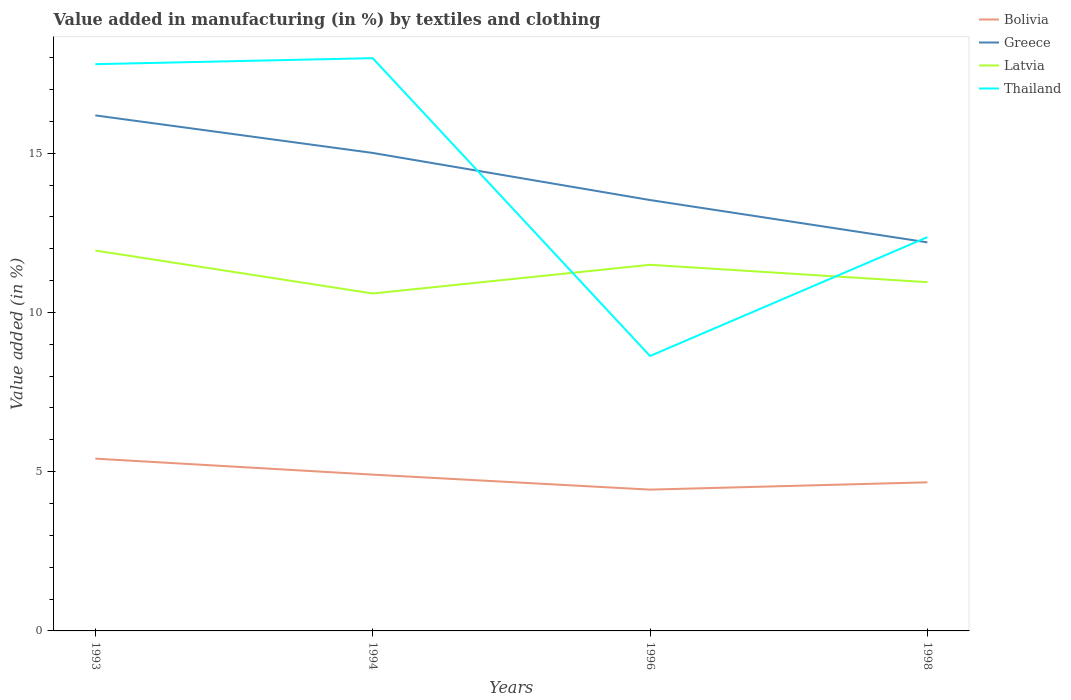How many different coloured lines are there?
Your response must be concise. 4. Across all years, what is the maximum percentage of value added in manufacturing by textiles and clothing in Latvia?
Provide a short and direct response. 10.59. What is the total percentage of value added in manufacturing by textiles and clothing in Greece in the graph?
Provide a succinct answer. 1.18. What is the difference between the highest and the second highest percentage of value added in manufacturing by textiles and clothing in Bolivia?
Keep it short and to the point. 0.97. Is the percentage of value added in manufacturing by textiles and clothing in Latvia strictly greater than the percentage of value added in manufacturing by textiles and clothing in Bolivia over the years?
Keep it short and to the point. No. How many lines are there?
Ensure brevity in your answer.  4. What is the difference between two consecutive major ticks on the Y-axis?
Offer a terse response. 5. Are the values on the major ticks of Y-axis written in scientific E-notation?
Your answer should be compact. No. Does the graph contain any zero values?
Your answer should be very brief. No. What is the title of the graph?
Keep it short and to the point. Value added in manufacturing (in %) by textiles and clothing. Does "Vanuatu" appear as one of the legend labels in the graph?
Offer a terse response. No. What is the label or title of the Y-axis?
Make the answer very short. Value added (in %). What is the Value added (in %) in Bolivia in 1993?
Provide a short and direct response. 5.41. What is the Value added (in %) in Greece in 1993?
Keep it short and to the point. 16.19. What is the Value added (in %) of Latvia in 1993?
Offer a terse response. 11.94. What is the Value added (in %) in Thailand in 1993?
Your answer should be very brief. 17.79. What is the Value added (in %) in Bolivia in 1994?
Ensure brevity in your answer.  4.91. What is the Value added (in %) in Greece in 1994?
Make the answer very short. 15.01. What is the Value added (in %) in Latvia in 1994?
Your answer should be very brief. 10.59. What is the Value added (in %) of Thailand in 1994?
Make the answer very short. 17.98. What is the Value added (in %) of Bolivia in 1996?
Offer a terse response. 4.44. What is the Value added (in %) of Greece in 1996?
Your answer should be very brief. 13.53. What is the Value added (in %) in Latvia in 1996?
Your answer should be compact. 11.5. What is the Value added (in %) of Thailand in 1996?
Make the answer very short. 8.63. What is the Value added (in %) in Bolivia in 1998?
Make the answer very short. 4.67. What is the Value added (in %) in Greece in 1998?
Provide a short and direct response. 12.2. What is the Value added (in %) of Latvia in 1998?
Make the answer very short. 10.95. What is the Value added (in %) of Thailand in 1998?
Your response must be concise. 12.36. Across all years, what is the maximum Value added (in %) of Bolivia?
Give a very brief answer. 5.41. Across all years, what is the maximum Value added (in %) of Greece?
Offer a terse response. 16.19. Across all years, what is the maximum Value added (in %) of Latvia?
Offer a terse response. 11.94. Across all years, what is the maximum Value added (in %) of Thailand?
Ensure brevity in your answer.  17.98. Across all years, what is the minimum Value added (in %) of Bolivia?
Provide a succinct answer. 4.44. Across all years, what is the minimum Value added (in %) in Greece?
Your answer should be compact. 12.2. Across all years, what is the minimum Value added (in %) of Latvia?
Your answer should be very brief. 10.59. Across all years, what is the minimum Value added (in %) of Thailand?
Provide a short and direct response. 8.63. What is the total Value added (in %) of Bolivia in the graph?
Offer a very short reply. 19.42. What is the total Value added (in %) of Greece in the graph?
Your response must be concise. 56.92. What is the total Value added (in %) in Latvia in the graph?
Your answer should be very brief. 44.98. What is the total Value added (in %) of Thailand in the graph?
Your answer should be compact. 56.77. What is the difference between the Value added (in %) of Bolivia in 1993 and that in 1994?
Make the answer very short. 0.5. What is the difference between the Value added (in %) in Greece in 1993 and that in 1994?
Make the answer very short. 1.18. What is the difference between the Value added (in %) of Latvia in 1993 and that in 1994?
Give a very brief answer. 1.35. What is the difference between the Value added (in %) in Thailand in 1993 and that in 1994?
Give a very brief answer. -0.19. What is the difference between the Value added (in %) in Bolivia in 1993 and that in 1996?
Provide a short and direct response. 0.97. What is the difference between the Value added (in %) of Greece in 1993 and that in 1996?
Provide a succinct answer. 2.66. What is the difference between the Value added (in %) in Latvia in 1993 and that in 1996?
Offer a terse response. 0.45. What is the difference between the Value added (in %) in Thailand in 1993 and that in 1996?
Make the answer very short. 9.16. What is the difference between the Value added (in %) in Bolivia in 1993 and that in 1998?
Ensure brevity in your answer.  0.74. What is the difference between the Value added (in %) of Greece in 1993 and that in 1998?
Your answer should be very brief. 3.99. What is the difference between the Value added (in %) of Thailand in 1993 and that in 1998?
Your response must be concise. 5.43. What is the difference between the Value added (in %) of Bolivia in 1994 and that in 1996?
Give a very brief answer. 0.47. What is the difference between the Value added (in %) in Greece in 1994 and that in 1996?
Offer a terse response. 1.48. What is the difference between the Value added (in %) in Latvia in 1994 and that in 1996?
Your answer should be very brief. -0.9. What is the difference between the Value added (in %) of Thailand in 1994 and that in 1996?
Provide a succinct answer. 9.35. What is the difference between the Value added (in %) of Bolivia in 1994 and that in 1998?
Provide a succinct answer. 0.24. What is the difference between the Value added (in %) in Greece in 1994 and that in 1998?
Provide a succinct answer. 2.81. What is the difference between the Value added (in %) of Latvia in 1994 and that in 1998?
Your answer should be compact. -0.35. What is the difference between the Value added (in %) in Thailand in 1994 and that in 1998?
Ensure brevity in your answer.  5.62. What is the difference between the Value added (in %) of Bolivia in 1996 and that in 1998?
Your answer should be very brief. -0.23. What is the difference between the Value added (in %) in Greece in 1996 and that in 1998?
Your answer should be very brief. 1.33. What is the difference between the Value added (in %) of Latvia in 1996 and that in 1998?
Offer a terse response. 0.55. What is the difference between the Value added (in %) in Thailand in 1996 and that in 1998?
Offer a terse response. -3.73. What is the difference between the Value added (in %) of Bolivia in 1993 and the Value added (in %) of Greece in 1994?
Your response must be concise. -9.6. What is the difference between the Value added (in %) in Bolivia in 1993 and the Value added (in %) in Latvia in 1994?
Provide a succinct answer. -5.19. What is the difference between the Value added (in %) of Bolivia in 1993 and the Value added (in %) of Thailand in 1994?
Keep it short and to the point. -12.57. What is the difference between the Value added (in %) in Greece in 1993 and the Value added (in %) in Latvia in 1994?
Offer a terse response. 5.59. What is the difference between the Value added (in %) of Greece in 1993 and the Value added (in %) of Thailand in 1994?
Provide a short and direct response. -1.8. What is the difference between the Value added (in %) in Latvia in 1993 and the Value added (in %) in Thailand in 1994?
Keep it short and to the point. -6.04. What is the difference between the Value added (in %) of Bolivia in 1993 and the Value added (in %) of Greece in 1996?
Keep it short and to the point. -8.12. What is the difference between the Value added (in %) of Bolivia in 1993 and the Value added (in %) of Latvia in 1996?
Provide a succinct answer. -6.09. What is the difference between the Value added (in %) of Bolivia in 1993 and the Value added (in %) of Thailand in 1996?
Ensure brevity in your answer.  -3.22. What is the difference between the Value added (in %) of Greece in 1993 and the Value added (in %) of Latvia in 1996?
Keep it short and to the point. 4.69. What is the difference between the Value added (in %) of Greece in 1993 and the Value added (in %) of Thailand in 1996?
Offer a terse response. 7.55. What is the difference between the Value added (in %) of Latvia in 1993 and the Value added (in %) of Thailand in 1996?
Ensure brevity in your answer.  3.31. What is the difference between the Value added (in %) of Bolivia in 1993 and the Value added (in %) of Greece in 1998?
Offer a very short reply. -6.79. What is the difference between the Value added (in %) in Bolivia in 1993 and the Value added (in %) in Latvia in 1998?
Keep it short and to the point. -5.54. What is the difference between the Value added (in %) in Bolivia in 1993 and the Value added (in %) in Thailand in 1998?
Offer a very short reply. -6.95. What is the difference between the Value added (in %) in Greece in 1993 and the Value added (in %) in Latvia in 1998?
Keep it short and to the point. 5.24. What is the difference between the Value added (in %) of Greece in 1993 and the Value added (in %) of Thailand in 1998?
Your response must be concise. 3.82. What is the difference between the Value added (in %) in Latvia in 1993 and the Value added (in %) in Thailand in 1998?
Give a very brief answer. -0.42. What is the difference between the Value added (in %) in Bolivia in 1994 and the Value added (in %) in Greece in 1996?
Your answer should be compact. -8.62. What is the difference between the Value added (in %) of Bolivia in 1994 and the Value added (in %) of Latvia in 1996?
Your answer should be compact. -6.59. What is the difference between the Value added (in %) in Bolivia in 1994 and the Value added (in %) in Thailand in 1996?
Your answer should be compact. -3.72. What is the difference between the Value added (in %) of Greece in 1994 and the Value added (in %) of Latvia in 1996?
Ensure brevity in your answer.  3.51. What is the difference between the Value added (in %) of Greece in 1994 and the Value added (in %) of Thailand in 1996?
Provide a short and direct response. 6.38. What is the difference between the Value added (in %) in Latvia in 1994 and the Value added (in %) in Thailand in 1996?
Give a very brief answer. 1.96. What is the difference between the Value added (in %) in Bolivia in 1994 and the Value added (in %) in Greece in 1998?
Offer a very short reply. -7.29. What is the difference between the Value added (in %) of Bolivia in 1994 and the Value added (in %) of Latvia in 1998?
Provide a short and direct response. -6.04. What is the difference between the Value added (in %) in Bolivia in 1994 and the Value added (in %) in Thailand in 1998?
Offer a terse response. -7.46. What is the difference between the Value added (in %) in Greece in 1994 and the Value added (in %) in Latvia in 1998?
Offer a terse response. 4.06. What is the difference between the Value added (in %) of Greece in 1994 and the Value added (in %) of Thailand in 1998?
Your response must be concise. 2.64. What is the difference between the Value added (in %) of Latvia in 1994 and the Value added (in %) of Thailand in 1998?
Give a very brief answer. -1.77. What is the difference between the Value added (in %) of Bolivia in 1996 and the Value added (in %) of Greece in 1998?
Provide a succinct answer. -7.76. What is the difference between the Value added (in %) in Bolivia in 1996 and the Value added (in %) in Latvia in 1998?
Your response must be concise. -6.51. What is the difference between the Value added (in %) in Bolivia in 1996 and the Value added (in %) in Thailand in 1998?
Provide a short and direct response. -7.93. What is the difference between the Value added (in %) in Greece in 1996 and the Value added (in %) in Latvia in 1998?
Provide a short and direct response. 2.58. What is the difference between the Value added (in %) of Greece in 1996 and the Value added (in %) of Thailand in 1998?
Your answer should be very brief. 1.16. What is the difference between the Value added (in %) in Latvia in 1996 and the Value added (in %) in Thailand in 1998?
Your response must be concise. -0.87. What is the average Value added (in %) of Bolivia per year?
Your answer should be very brief. 4.85. What is the average Value added (in %) of Greece per year?
Your answer should be very brief. 14.23. What is the average Value added (in %) in Latvia per year?
Your answer should be compact. 11.25. What is the average Value added (in %) in Thailand per year?
Provide a short and direct response. 14.19. In the year 1993, what is the difference between the Value added (in %) in Bolivia and Value added (in %) in Greece?
Offer a terse response. -10.78. In the year 1993, what is the difference between the Value added (in %) of Bolivia and Value added (in %) of Latvia?
Keep it short and to the point. -6.53. In the year 1993, what is the difference between the Value added (in %) in Bolivia and Value added (in %) in Thailand?
Offer a very short reply. -12.38. In the year 1993, what is the difference between the Value added (in %) in Greece and Value added (in %) in Latvia?
Make the answer very short. 4.24. In the year 1993, what is the difference between the Value added (in %) of Greece and Value added (in %) of Thailand?
Provide a succinct answer. -1.61. In the year 1993, what is the difference between the Value added (in %) in Latvia and Value added (in %) in Thailand?
Your answer should be compact. -5.85. In the year 1994, what is the difference between the Value added (in %) in Bolivia and Value added (in %) in Greece?
Keep it short and to the point. -10.1. In the year 1994, what is the difference between the Value added (in %) of Bolivia and Value added (in %) of Latvia?
Your response must be concise. -5.69. In the year 1994, what is the difference between the Value added (in %) in Bolivia and Value added (in %) in Thailand?
Provide a succinct answer. -13.08. In the year 1994, what is the difference between the Value added (in %) in Greece and Value added (in %) in Latvia?
Your answer should be compact. 4.41. In the year 1994, what is the difference between the Value added (in %) of Greece and Value added (in %) of Thailand?
Offer a very short reply. -2.98. In the year 1994, what is the difference between the Value added (in %) of Latvia and Value added (in %) of Thailand?
Give a very brief answer. -7.39. In the year 1996, what is the difference between the Value added (in %) of Bolivia and Value added (in %) of Greece?
Provide a short and direct response. -9.09. In the year 1996, what is the difference between the Value added (in %) of Bolivia and Value added (in %) of Latvia?
Make the answer very short. -7.06. In the year 1996, what is the difference between the Value added (in %) of Bolivia and Value added (in %) of Thailand?
Ensure brevity in your answer.  -4.2. In the year 1996, what is the difference between the Value added (in %) of Greece and Value added (in %) of Latvia?
Your answer should be compact. 2.03. In the year 1996, what is the difference between the Value added (in %) in Greece and Value added (in %) in Thailand?
Ensure brevity in your answer.  4.9. In the year 1996, what is the difference between the Value added (in %) in Latvia and Value added (in %) in Thailand?
Ensure brevity in your answer.  2.86. In the year 1998, what is the difference between the Value added (in %) of Bolivia and Value added (in %) of Greece?
Offer a very short reply. -7.53. In the year 1998, what is the difference between the Value added (in %) of Bolivia and Value added (in %) of Latvia?
Your response must be concise. -6.28. In the year 1998, what is the difference between the Value added (in %) of Bolivia and Value added (in %) of Thailand?
Offer a terse response. -7.7. In the year 1998, what is the difference between the Value added (in %) of Greece and Value added (in %) of Latvia?
Give a very brief answer. 1.25. In the year 1998, what is the difference between the Value added (in %) in Greece and Value added (in %) in Thailand?
Your answer should be very brief. -0.16. In the year 1998, what is the difference between the Value added (in %) in Latvia and Value added (in %) in Thailand?
Your answer should be compact. -1.41. What is the ratio of the Value added (in %) in Bolivia in 1993 to that in 1994?
Your answer should be very brief. 1.1. What is the ratio of the Value added (in %) of Greece in 1993 to that in 1994?
Your response must be concise. 1.08. What is the ratio of the Value added (in %) in Latvia in 1993 to that in 1994?
Ensure brevity in your answer.  1.13. What is the ratio of the Value added (in %) of Bolivia in 1993 to that in 1996?
Offer a terse response. 1.22. What is the ratio of the Value added (in %) in Greece in 1993 to that in 1996?
Ensure brevity in your answer.  1.2. What is the ratio of the Value added (in %) in Latvia in 1993 to that in 1996?
Your response must be concise. 1.04. What is the ratio of the Value added (in %) of Thailand in 1993 to that in 1996?
Provide a short and direct response. 2.06. What is the ratio of the Value added (in %) of Bolivia in 1993 to that in 1998?
Keep it short and to the point. 1.16. What is the ratio of the Value added (in %) of Greece in 1993 to that in 1998?
Make the answer very short. 1.33. What is the ratio of the Value added (in %) in Latvia in 1993 to that in 1998?
Offer a terse response. 1.09. What is the ratio of the Value added (in %) of Thailand in 1993 to that in 1998?
Offer a very short reply. 1.44. What is the ratio of the Value added (in %) in Bolivia in 1994 to that in 1996?
Provide a succinct answer. 1.11. What is the ratio of the Value added (in %) in Greece in 1994 to that in 1996?
Offer a terse response. 1.11. What is the ratio of the Value added (in %) in Latvia in 1994 to that in 1996?
Your response must be concise. 0.92. What is the ratio of the Value added (in %) of Thailand in 1994 to that in 1996?
Provide a short and direct response. 2.08. What is the ratio of the Value added (in %) in Bolivia in 1994 to that in 1998?
Make the answer very short. 1.05. What is the ratio of the Value added (in %) in Greece in 1994 to that in 1998?
Provide a succinct answer. 1.23. What is the ratio of the Value added (in %) of Latvia in 1994 to that in 1998?
Provide a short and direct response. 0.97. What is the ratio of the Value added (in %) of Thailand in 1994 to that in 1998?
Offer a very short reply. 1.45. What is the ratio of the Value added (in %) in Bolivia in 1996 to that in 1998?
Offer a very short reply. 0.95. What is the ratio of the Value added (in %) in Greece in 1996 to that in 1998?
Offer a very short reply. 1.11. What is the ratio of the Value added (in %) of Latvia in 1996 to that in 1998?
Provide a succinct answer. 1.05. What is the ratio of the Value added (in %) in Thailand in 1996 to that in 1998?
Keep it short and to the point. 0.7. What is the difference between the highest and the second highest Value added (in %) in Bolivia?
Offer a terse response. 0.5. What is the difference between the highest and the second highest Value added (in %) of Greece?
Give a very brief answer. 1.18. What is the difference between the highest and the second highest Value added (in %) of Latvia?
Ensure brevity in your answer.  0.45. What is the difference between the highest and the second highest Value added (in %) in Thailand?
Offer a very short reply. 0.19. What is the difference between the highest and the lowest Value added (in %) of Bolivia?
Ensure brevity in your answer.  0.97. What is the difference between the highest and the lowest Value added (in %) in Greece?
Ensure brevity in your answer.  3.99. What is the difference between the highest and the lowest Value added (in %) of Latvia?
Ensure brevity in your answer.  1.35. What is the difference between the highest and the lowest Value added (in %) of Thailand?
Your answer should be compact. 9.35. 